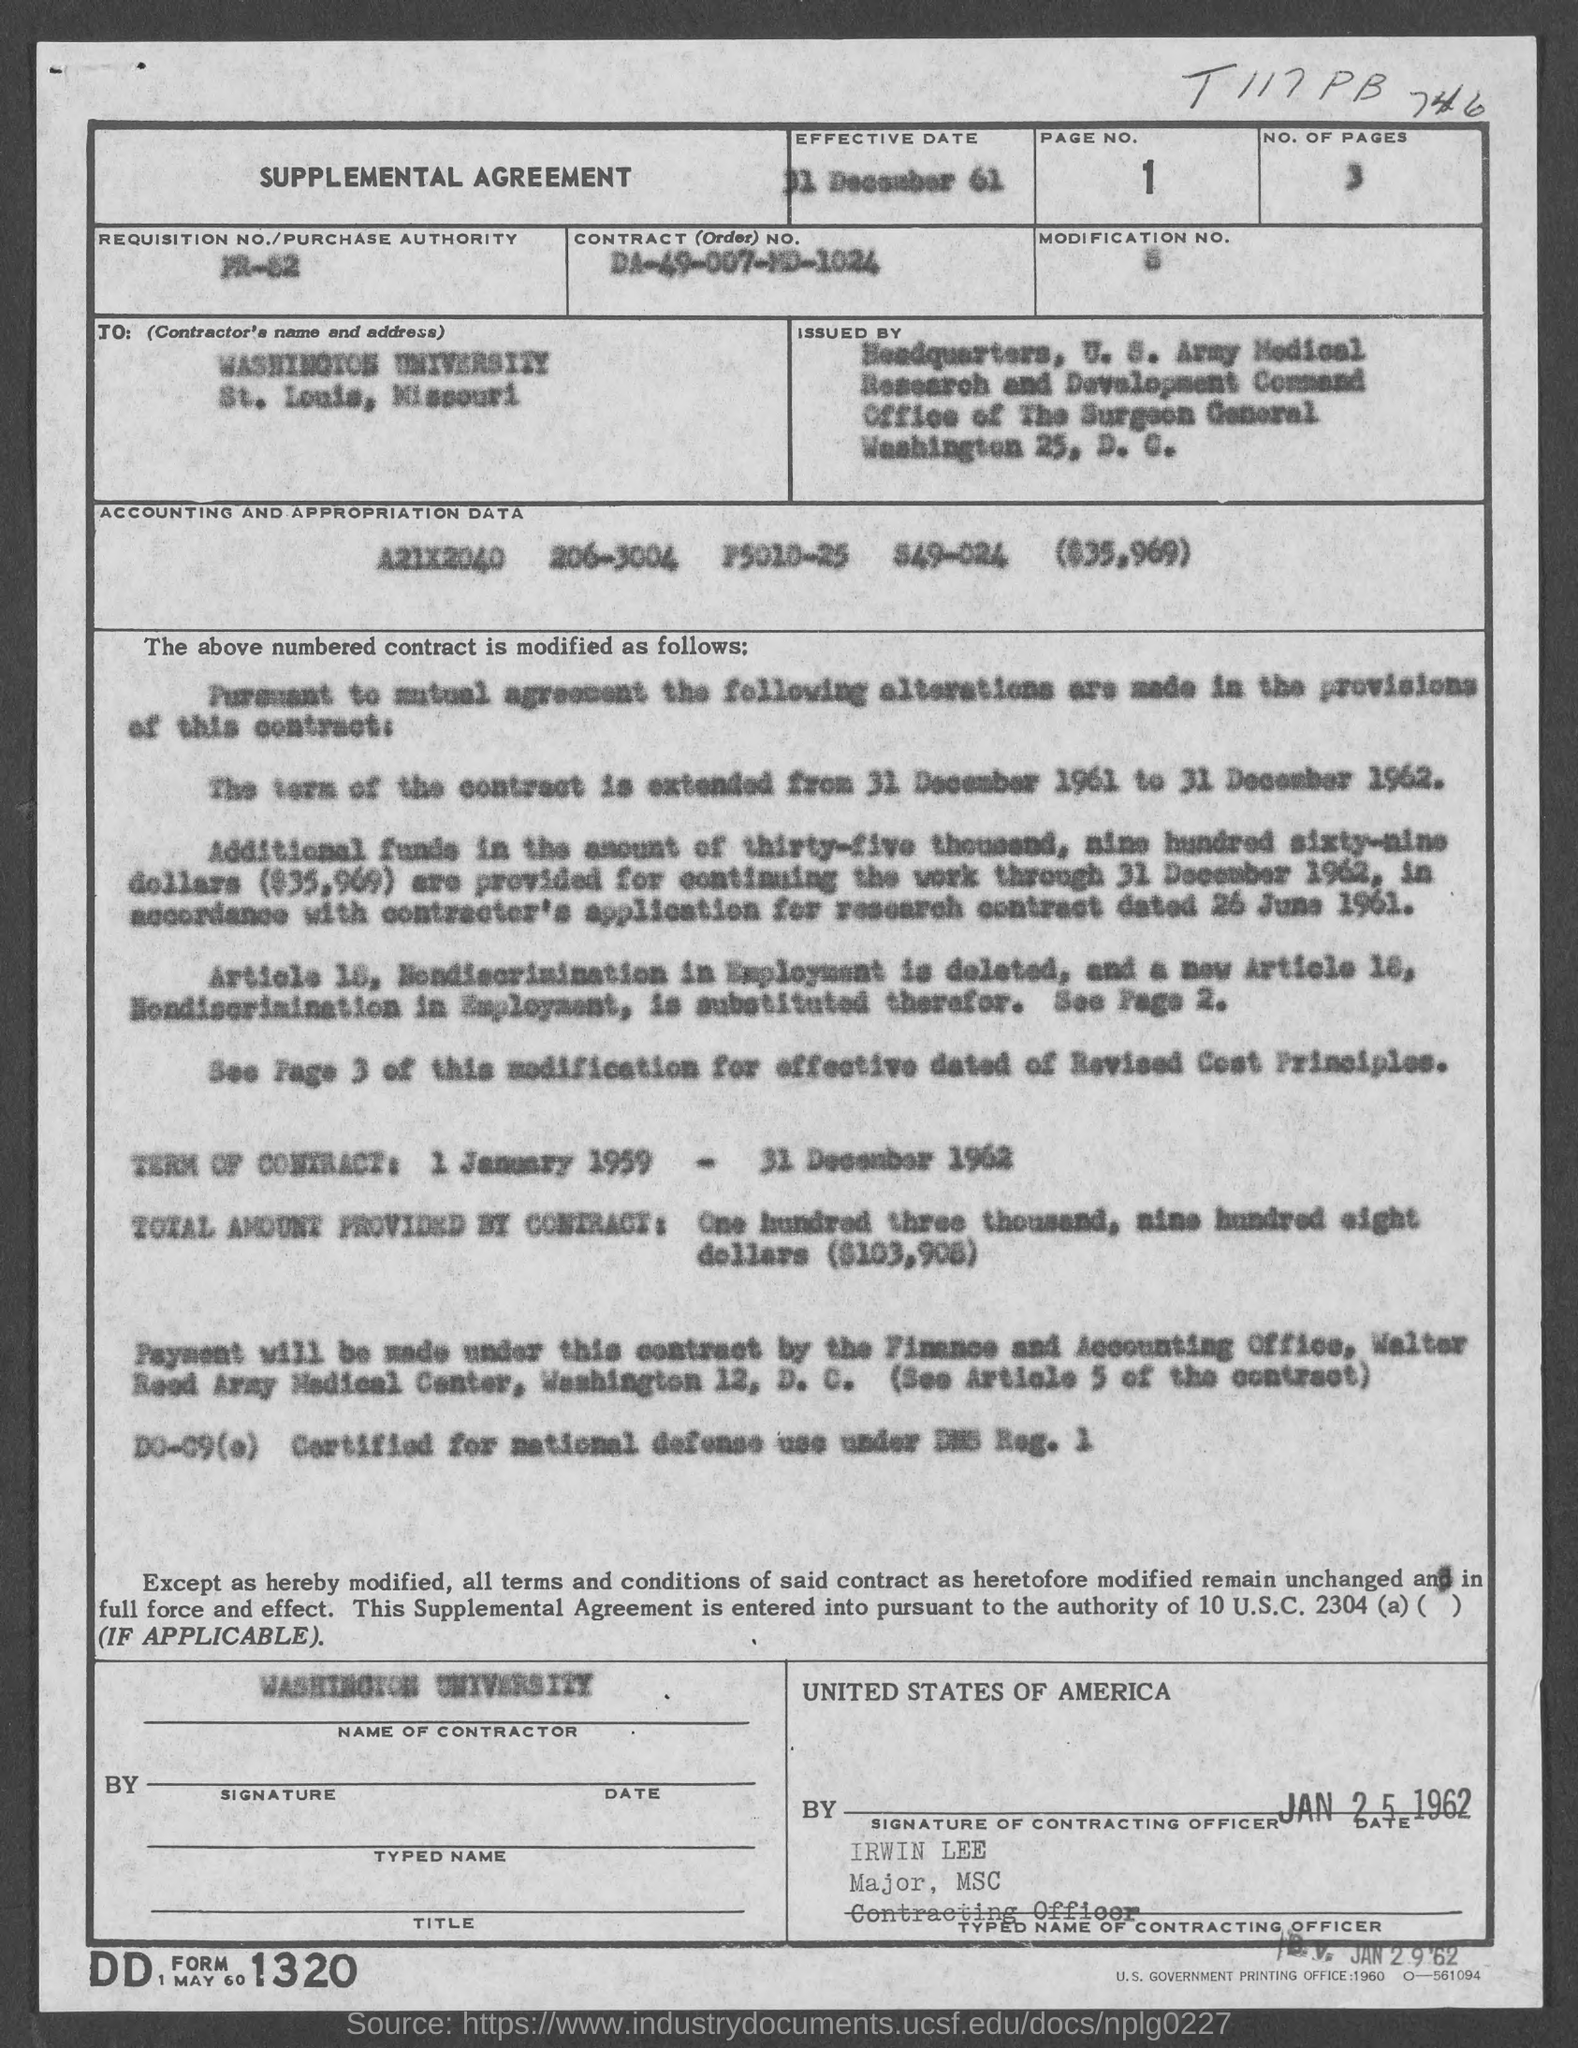Draw attention to some important aspects in this diagram. The number of pages is 3. I am seeking to determine the page number and range of information related to a specific topic, from the first page to the most recent update. The contract number is DA-49-007-MD-1024. The effective date is 31 December 1961," stated the document. 